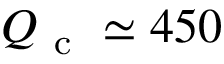<formula> <loc_0><loc_0><loc_500><loc_500>{ Q _ { c } } \simeq 4 5 0</formula> 